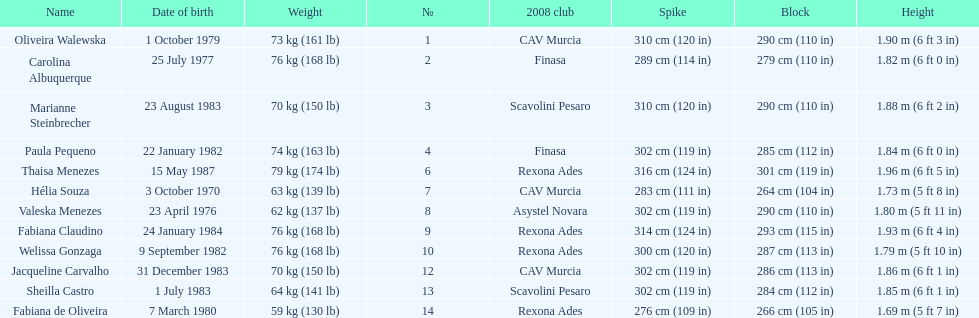What are all of the names? Oliveira Walewska, Carolina Albuquerque, Marianne Steinbrecher, Paula Pequeno, Thaisa Menezes, Hélia Souza, Valeska Menezes, Fabiana Claudino, Welissa Gonzaga, Jacqueline Carvalho, Sheilla Castro, Fabiana de Oliveira. What are their weights? 73 kg (161 lb), 76 kg (168 lb), 70 kg (150 lb), 74 kg (163 lb), 79 kg (174 lb), 63 kg (139 lb), 62 kg (137 lb), 76 kg (168 lb), 76 kg (168 lb), 70 kg (150 lb), 64 kg (141 lb), 59 kg (130 lb). How much did helia souza, fabiana de oliveira, and sheilla castro weigh? Hélia Souza, Sheilla Castro, Fabiana de Oliveira. And who weighed more? Sheilla Castro. 